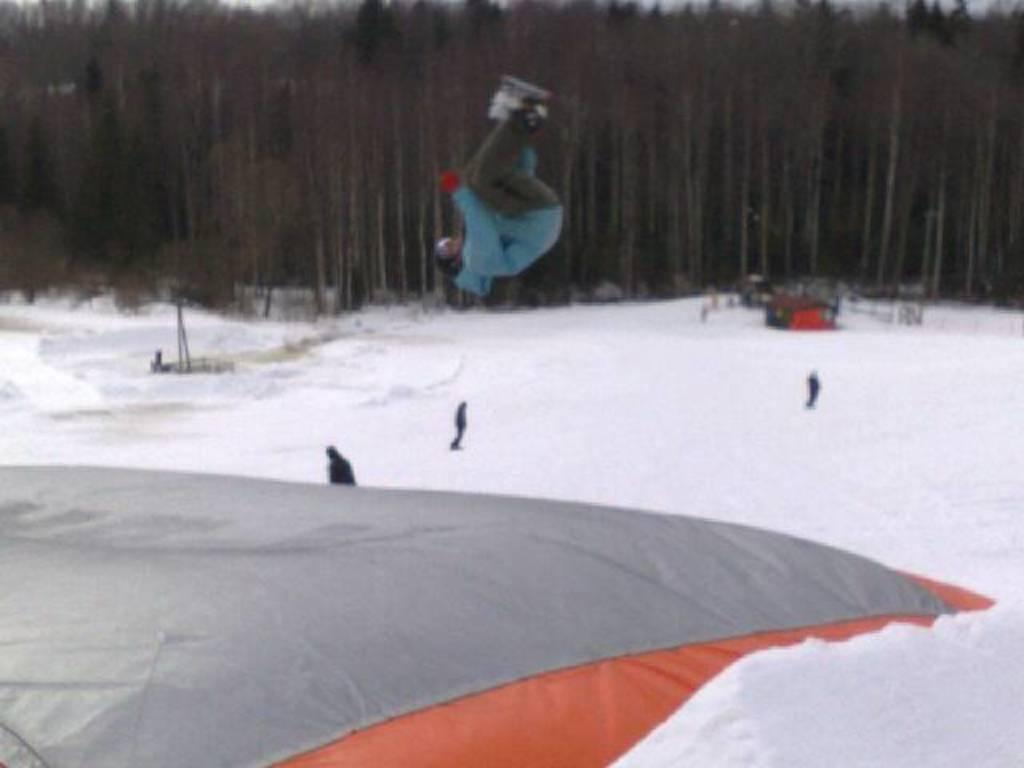Can you describe this image briefly? This picture is clicked outside. In the foreground we can see there is a lot of snow and we can see the group of persons and an object which seems to be the cloth and we can see a person in the air. In the background we can see the trees and some other objects. 